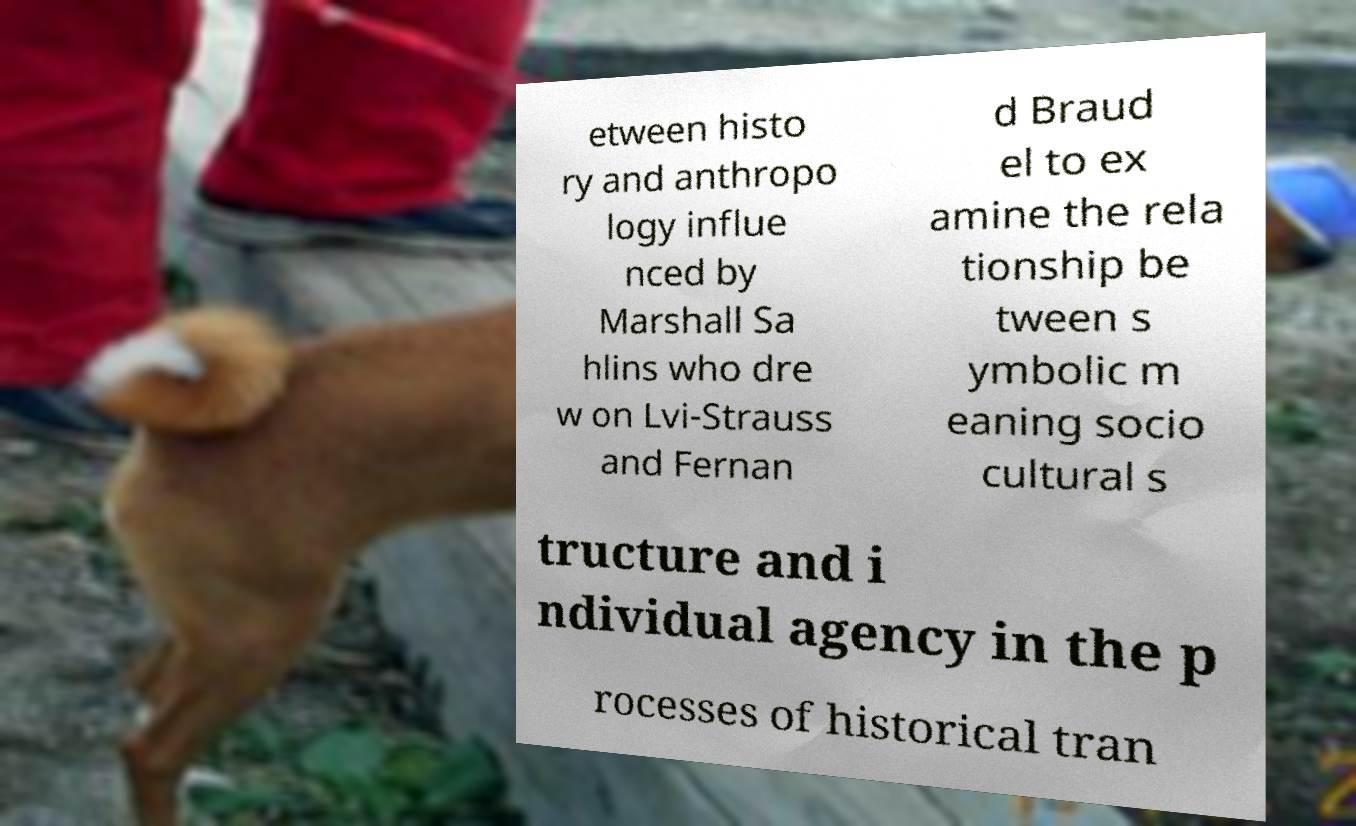Could you extract and type out the text from this image? etween histo ry and anthropo logy influe nced by Marshall Sa hlins who dre w on Lvi-Strauss and Fernan d Braud el to ex amine the rela tionship be tween s ymbolic m eaning socio cultural s tructure and i ndividual agency in the p rocesses of historical tran 